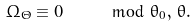<formula> <loc_0><loc_0><loc_500><loc_500>\Omega _ { \Theta } \equiv 0 \quad \mod \theta _ { 0 } , \, \theta .</formula> 